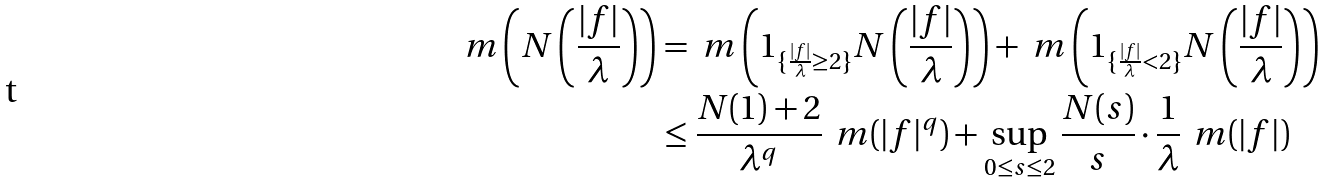<formula> <loc_0><loc_0><loc_500><loc_500>\ m \left ( N \left ( \frac { | f | } { \lambda } \right ) \right ) & = \ m \left ( 1 _ { \{ \frac { | f | } { \lambda } \geq 2 \} } N \left ( \frac { | f | } { \lambda } \right ) \right ) + \ m \left ( 1 _ { \{ \frac { | f | } { \lambda } < 2 \} } N \left ( \frac { | f | } { \lambda } \right ) \right ) \\ & \leq \frac { N ( 1 ) + 2 } { \lambda ^ { q } } \, \ m ( | f | ^ { q } ) + \sup _ { 0 \leq s \leq 2 } \frac { N ( s ) } { s } \cdot \frac { 1 } { \lambda } \, \ m ( | f | )</formula> 